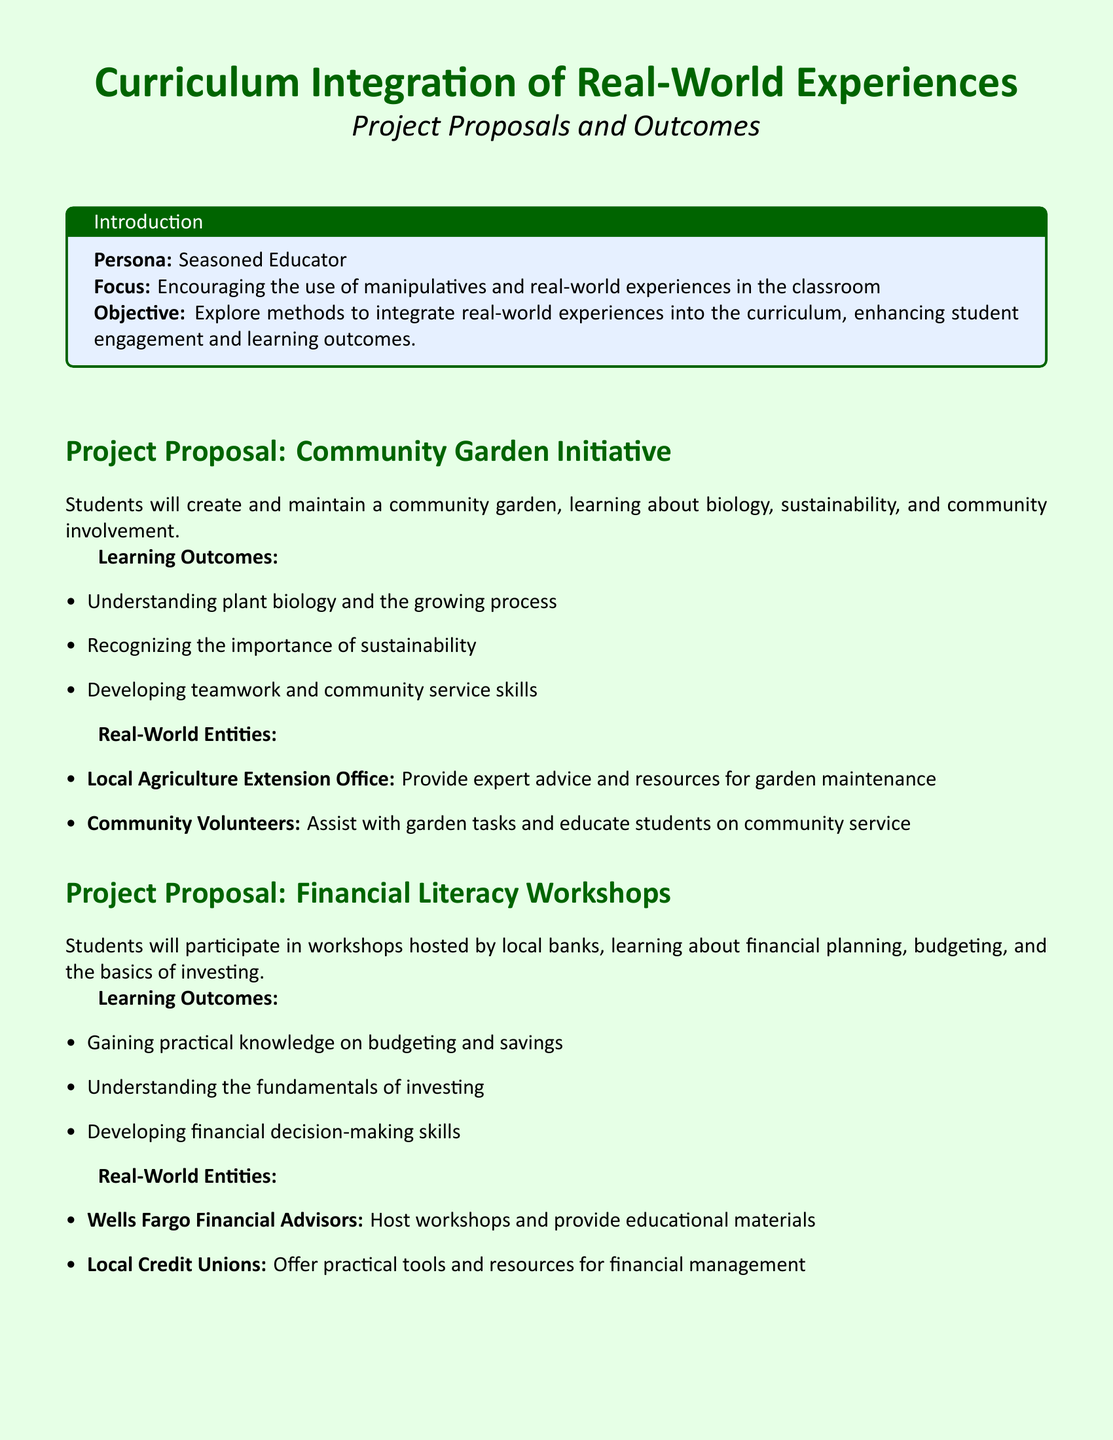What is the title of the first project proposal? The first project proposal is titled "Community Garden Initiative."
Answer: Community Garden Initiative What is one learning outcome of the Financial Literacy Workshops? One learning outcome is understanding the fundamentals of investing.
Answer: Understanding the fundamentals of investing Which real-world entity provides mentorship for the Engineering Challenges? The real-world entity providing mentorship is General Electric.
Answer: General Electric What skills are developed through the Community Garden Initiative? Skills developed include teamwork and community service skills.
Answer: Teamwork and community service skills How many project proposals are listed in the document? There are three project proposals listed in the document.
Answer: Three What type of workshops do local banks host? The workshops hosted by local banks are focused on financial planning and budgeting.
Answer: Financial planning and budgeting Which local organization assists with garden tasks in the Community Garden Initiative? Community Volunteers assist with garden tasks.
Answer: Community Volunteers What is the overall objective of the document? The overall objective is to explore methods to integrate real-world experiences into the curriculum.
Answer: Integrate real-world experiences into the curriculum What type of experience is emphasized throughout the document? The document emphasizes real-world experiences.
Answer: Real-world experiences 